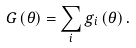Convert formula to latex. <formula><loc_0><loc_0><loc_500><loc_500>G \left ( \theta \right ) = \sum _ { i } g _ { i } \left ( \theta \right ) .</formula> 